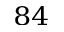Convert formula to latex. <formula><loc_0><loc_0><loc_500><loc_500>^ { 8 4 }</formula> 